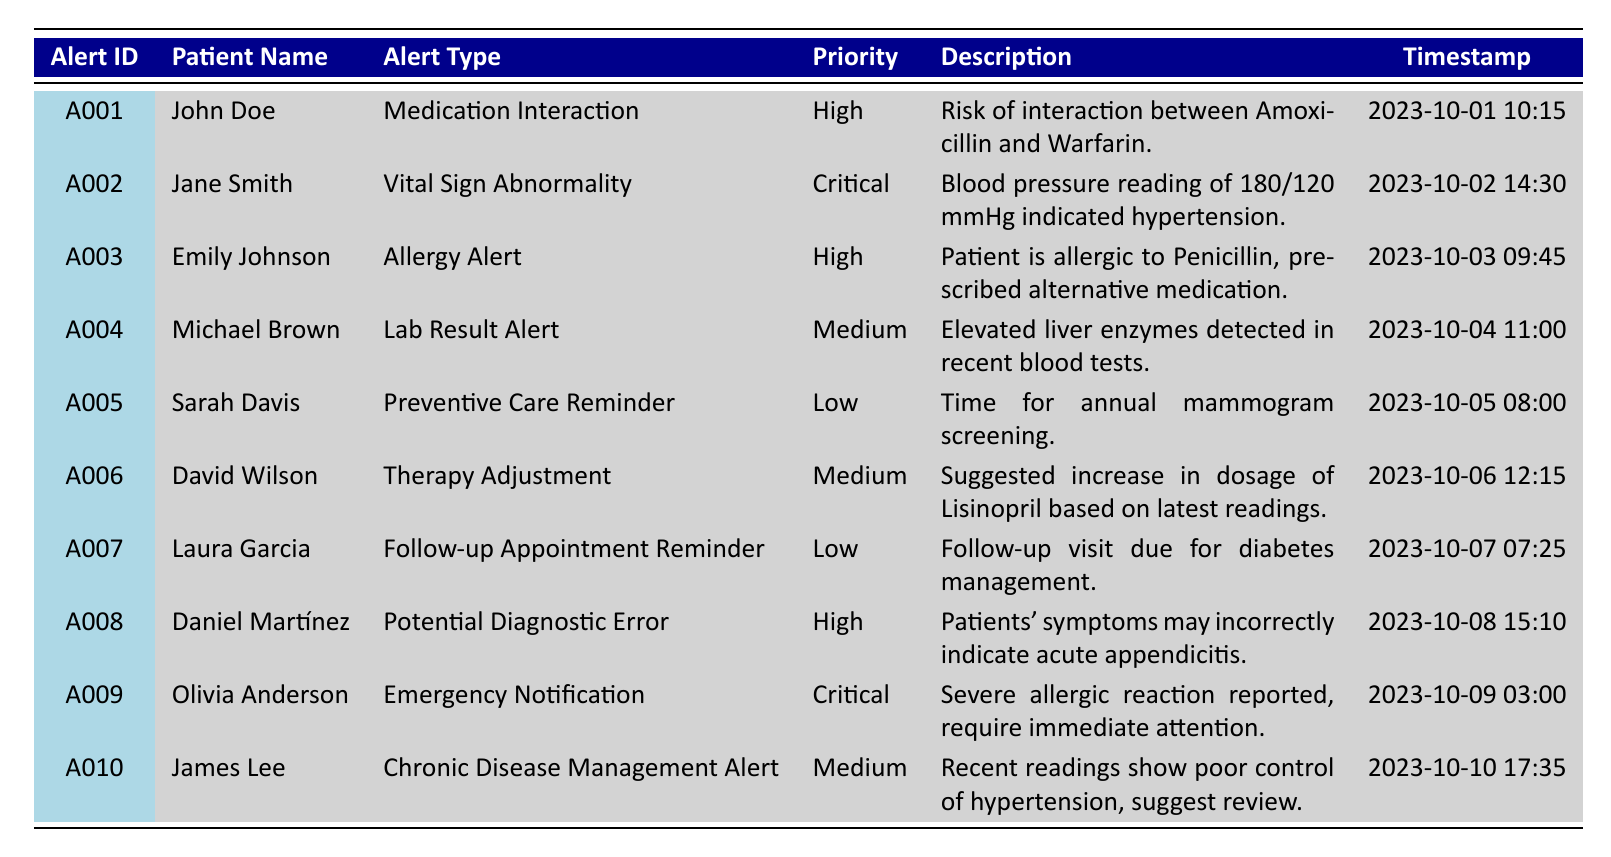What is the alert type for John Doe? The table shows that John Doe has an alert type listed under the "Alert Type" column associated with his record, which is "Medication Interaction."
Answer: Medication Interaction How many alerts were labeled as "Critical"? The table contains two critical alerts, specifically those for Jane Smith and Olivia Anderson. Counting these two entries gives us the total.
Answer: 2 Which patient has an alert regarding a therapy adjustment? The entry for David Wilson specifies a "Therapy Adjustment" alert in the "Alert Type" column.
Answer: David Wilson What was the priority level of the alert for Sarah Davis? In the table, the alert for Sarah Davis is categorized under the "Priority" column as "Low."
Answer: Low Is there an alert for a lab result? There is a specific entry in the table for Michael Brown, which mentions a "Lab Result Alert." Therefore, the answer is yes.
Answer: Yes What alert type has the highest priority among the listed alerts? Reviewing the priority levels, the types "Critical" and "High" stand out. However, two alerts are labeled as "Critical," which is the highest priority, suggesting that alerts for Jane Smith and Olivia Anderson represent the highest priority types.
Answer: Critical What is the total number of patients mentioned in this table? By counting the unique patient IDs listed in the table, we see there are ten unique patients, as each alert corresponds to a different patient.
Answer: 10 Which patients received an alert for allergies? Emily Johnson received an "Allergy Alert," and this is clearly stated in her record. Thus, she is the only patient with such an alert.
Answer: Emily Johnson How many alerts have a priority level of "Medium"? The table lists three alerts with a "Medium" priority level for Michael Brown, David Wilson, and James Lee, allowing us to determine the total.
Answer: 3 Which alert description mentions hypertension? The description for Jane Smith notes "Blood pressure reading of 180/120 mmHg indicated hypertension," confirming that her alert relates to hypertension.
Answer: Jane Smith 